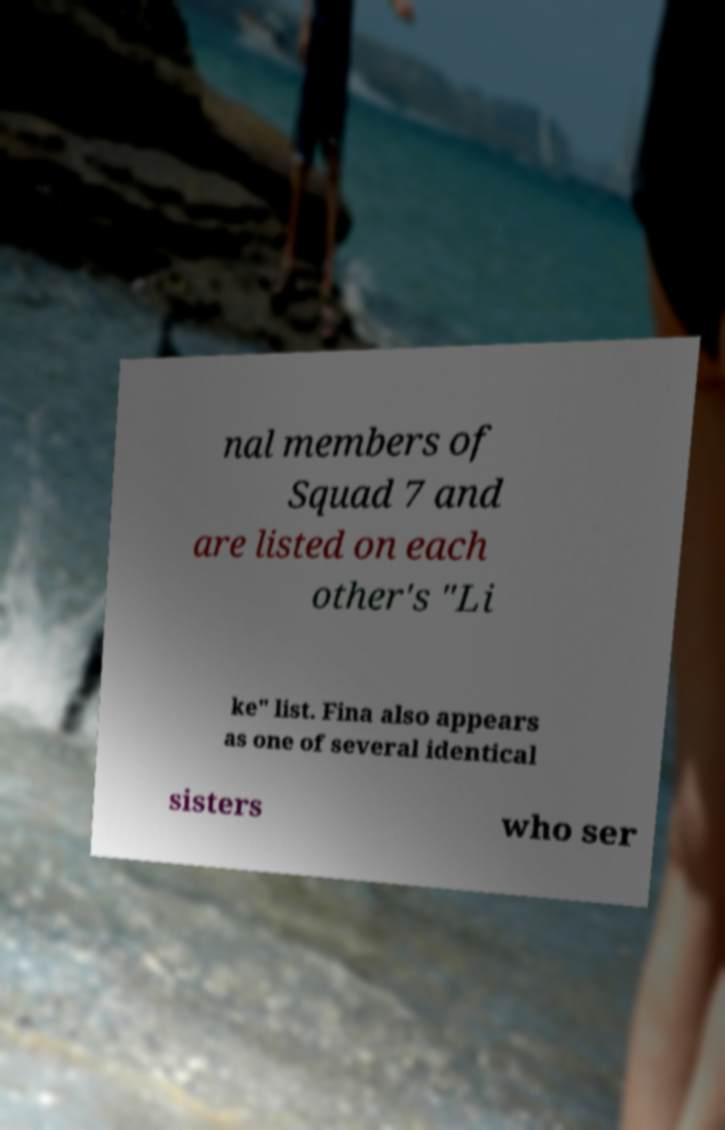Can you read and provide the text displayed in the image?This photo seems to have some interesting text. Can you extract and type it out for me? nal members of Squad 7 and are listed on each other's "Li ke" list. Fina also appears as one of several identical sisters who ser 